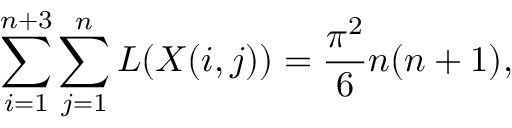<formula> <loc_0><loc_0><loc_500><loc_500>\sum _ { i = 1 } ^ { n + 3 } \sum _ { j = 1 } ^ { n } L ( X ( i , j ) ) = \frac { \pi ^ { 2 } } { 6 } n ( n + 1 ) ,</formula> 